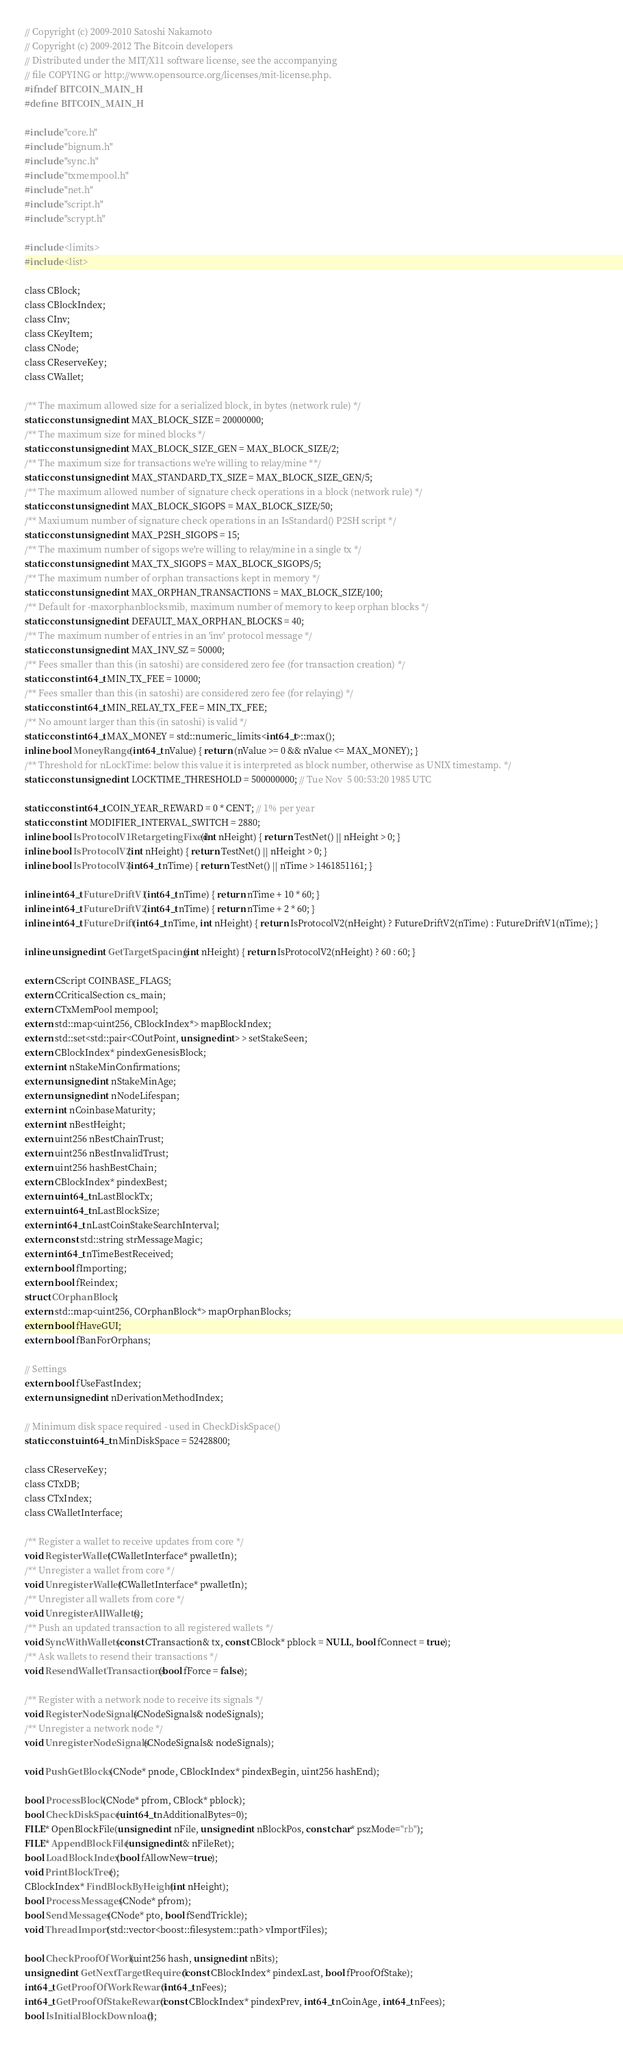<code> <loc_0><loc_0><loc_500><loc_500><_C_>// Copyright (c) 2009-2010 Satoshi Nakamoto
// Copyright (c) 2009-2012 The Bitcoin developers
// Distributed under the MIT/X11 software license, see the accompanying
// file COPYING or http://www.opensource.org/licenses/mit-license.php.
#ifndef BITCOIN_MAIN_H
#define BITCOIN_MAIN_H

#include "core.h"
#include "bignum.h"
#include "sync.h"
#include "txmempool.h"
#include "net.h"
#include "script.h"
#include "scrypt.h"

#include <limits>
#include <list>

class CBlock;
class CBlockIndex;
class CInv;
class CKeyItem;
class CNode;
class CReserveKey;
class CWallet;

/** The maximum allowed size for a serialized block, in bytes (network rule) */
static const unsigned int MAX_BLOCK_SIZE = 20000000;
/** The maximum size for mined blocks */
static const unsigned int MAX_BLOCK_SIZE_GEN = MAX_BLOCK_SIZE/2;
/** The maximum size for transactions we're willing to relay/mine **/
static const unsigned int MAX_STANDARD_TX_SIZE = MAX_BLOCK_SIZE_GEN/5;
/** The maximum allowed number of signature check operations in a block (network rule) */
static const unsigned int MAX_BLOCK_SIGOPS = MAX_BLOCK_SIZE/50;
/** Maxiumum number of signature check operations in an IsStandard() P2SH script */
static const unsigned int MAX_P2SH_SIGOPS = 15;
/** The maximum number of sigops we're willing to relay/mine in a single tx */
static const unsigned int MAX_TX_SIGOPS = MAX_BLOCK_SIGOPS/5;
/** The maximum number of orphan transactions kept in memory */
static const unsigned int MAX_ORPHAN_TRANSACTIONS = MAX_BLOCK_SIZE/100;
/** Default for -maxorphanblocksmib, maximum number of memory to keep orphan blocks */
static const unsigned int DEFAULT_MAX_ORPHAN_BLOCKS = 40;
/** The maximum number of entries in an 'inv' protocol message */
static const unsigned int MAX_INV_SZ = 50000;
/** Fees smaller than this (in satoshi) are considered zero fee (for transaction creation) */
static const int64_t MIN_TX_FEE = 10000;
/** Fees smaller than this (in satoshi) are considered zero fee (for relaying) */
static const int64_t MIN_RELAY_TX_FEE = MIN_TX_FEE;
/** No amount larger than this (in satoshi) is valid */
static const int64_t MAX_MONEY = std::numeric_limits<int64_t>::max();
inline bool MoneyRange(int64_t nValue) { return (nValue >= 0 && nValue <= MAX_MONEY); }
/** Threshold for nLockTime: below this value it is interpreted as block number, otherwise as UNIX timestamp. */
static const unsigned int LOCKTIME_THRESHOLD = 500000000; // Tue Nov  5 00:53:20 1985 UTC

static const int64_t COIN_YEAR_REWARD = 0 * CENT; // 1% per year
static const int MODIFIER_INTERVAL_SWITCH = 2880;
inline bool IsProtocolV1RetargetingFixed(int nHeight) { return TestNet() || nHeight > 0; }
inline bool IsProtocolV2(int nHeight) { return TestNet() || nHeight > 0; }
inline bool IsProtocolV3(int64_t nTime) { return TestNet() || nTime > 1461851161; }

inline int64_t FutureDriftV1(int64_t nTime) { return nTime + 10 * 60; }
inline int64_t FutureDriftV2(int64_t nTime) { return nTime + 2 * 60; }
inline int64_t FutureDrift(int64_t nTime, int nHeight) { return IsProtocolV2(nHeight) ? FutureDriftV2(nTime) : FutureDriftV1(nTime); }

inline unsigned int GetTargetSpacing(int nHeight) { return IsProtocolV2(nHeight) ? 60 : 60; }

extern CScript COINBASE_FLAGS;
extern CCriticalSection cs_main;
extern CTxMemPool mempool;
extern std::map<uint256, CBlockIndex*> mapBlockIndex;
extern std::set<std::pair<COutPoint, unsigned int> > setStakeSeen;
extern CBlockIndex* pindexGenesisBlock;
extern int nStakeMinConfirmations;
extern unsigned int nStakeMinAge;
extern unsigned int nNodeLifespan;
extern int nCoinbaseMaturity;
extern int nBestHeight;
extern uint256 nBestChainTrust;
extern uint256 nBestInvalidTrust;
extern uint256 hashBestChain;
extern CBlockIndex* pindexBest;
extern uint64_t nLastBlockTx;
extern uint64_t nLastBlockSize;
extern int64_t nLastCoinStakeSearchInterval;
extern const std::string strMessageMagic;
extern int64_t nTimeBestReceived;
extern bool fImporting;
extern bool fReindex;
struct COrphanBlock;
extern std::map<uint256, COrphanBlock*> mapOrphanBlocks;
extern bool fHaveGUI;
extern bool fBanForOrphans;

// Settings
extern bool fUseFastIndex;
extern unsigned int nDerivationMethodIndex;

// Minimum disk space required - used in CheckDiskSpace()
static const uint64_t nMinDiskSpace = 52428800;

class CReserveKey;
class CTxDB;
class CTxIndex;
class CWalletInterface;

/** Register a wallet to receive updates from core */
void RegisterWallet(CWalletInterface* pwalletIn);
/** Unregister a wallet from core */
void UnregisterWallet(CWalletInterface* pwalletIn);
/** Unregister all wallets from core */
void UnregisterAllWallets();
/** Push an updated transaction to all registered wallets */
void SyncWithWallets(const CTransaction& tx, const CBlock* pblock = NULL, bool fConnect = true);
/** Ask wallets to resend their transactions */
void ResendWalletTransactions(bool fForce = false);

/** Register with a network node to receive its signals */
void RegisterNodeSignals(CNodeSignals& nodeSignals);
/** Unregister a network node */
void UnregisterNodeSignals(CNodeSignals& nodeSignals);

void PushGetBlocks(CNode* pnode, CBlockIndex* pindexBegin, uint256 hashEnd);

bool ProcessBlock(CNode* pfrom, CBlock* pblock);
bool CheckDiskSpace(uint64_t nAdditionalBytes=0);
FILE* OpenBlockFile(unsigned int nFile, unsigned int nBlockPos, const char* pszMode="rb");
FILE* AppendBlockFile(unsigned int& nFileRet);
bool LoadBlockIndex(bool fAllowNew=true);
void PrintBlockTree();
CBlockIndex* FindBlockByHeight(int nHeight);
bool ProcessMessages(CNode* pfrom);
bool SendMessages(CNode* pto, bool fSendTrickle);
void ThreadImport(std::vector<boost::filesystem::path> vImportFiles);

bool CheckProofOfWork(uint256 hash, unsigned int nBits);
unsigned int GetNextTargetRequired(const CBlockIndex* pindexLast, bool fProofOfStake);
int64_t GetProofOfWorkReward(int64_t nFees);
int64_t GetProofOfStakeReward(const CBlockIndex* pindexPrev, int64_t nCoinAge, int64_t nFees);
bool IsInitialBlockDownload();</code> 